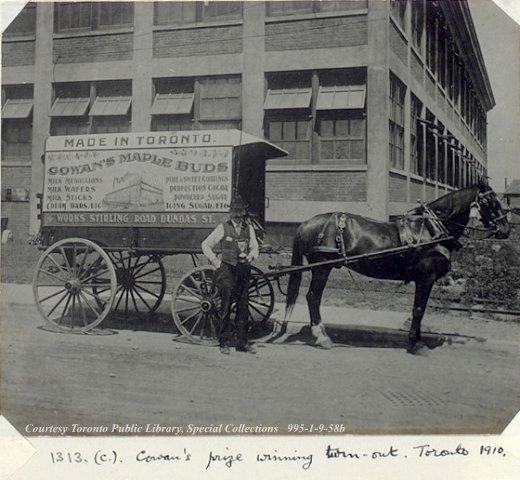How many horses?
Write a very short answer. 1. Is the carriage enclosed?
Be succinct. Yes. How many doors are on the building?
Keep it brief. 0. How many horses are in front of the wagon?
Be succinct. 1. What kind of business is advertised in the sign?
Give a very brief answer. Maple buds. Is this a modern time period?
Write a very short answer. No. Is the man selling goods?
Quick response, please. Yes. How many wheels are visible?
Give a very brief answer. 4. What number is in the bottom left corner?
Quick response, please. 1313. What country is the product made in?
Answer briefly. Canada. Are there decorations in the windows of the building?
Keep it brief. No. What year was this photo taken?
Answer briefly. 1910. Was this taken near a beach?
Quick response, please. No. 